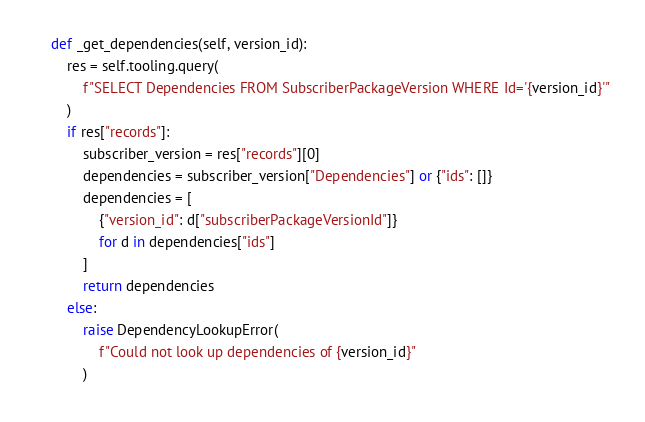Convert code to text. <code><loc_0><loc_0><loc_500><loc_500><_Python_>
    def _get_dependencies(self, version_id):
        res = self.tooling.query(
            f"SELECT Dependencies FROM SubscriberPackageVersion WHERE Id='{version_id}'"
        )
        if res["records"]:
            subscriber_version = res["records"][0]
            dependencies = subscriber_version["Dependencies"] or {"ids": []}
            dependencies = [
                {"version_id": d["subscriberPackageVersionId"]}
                for d in dependencies["ids"]
            ]
            return dependencies
        else:
            raise DependencyLookupError(
                f"Could not look up dependencies of {version_id}"
            )
</code> 